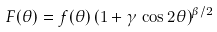Convert formula to latex. <formula><loc_0><loc_0><loc_500><loc_500>F ( \theta ) = f ( \theta ) \, ( 1 + \gamma \, \cos 2 \theta ) ^ { \beta / 2 }</formula> 